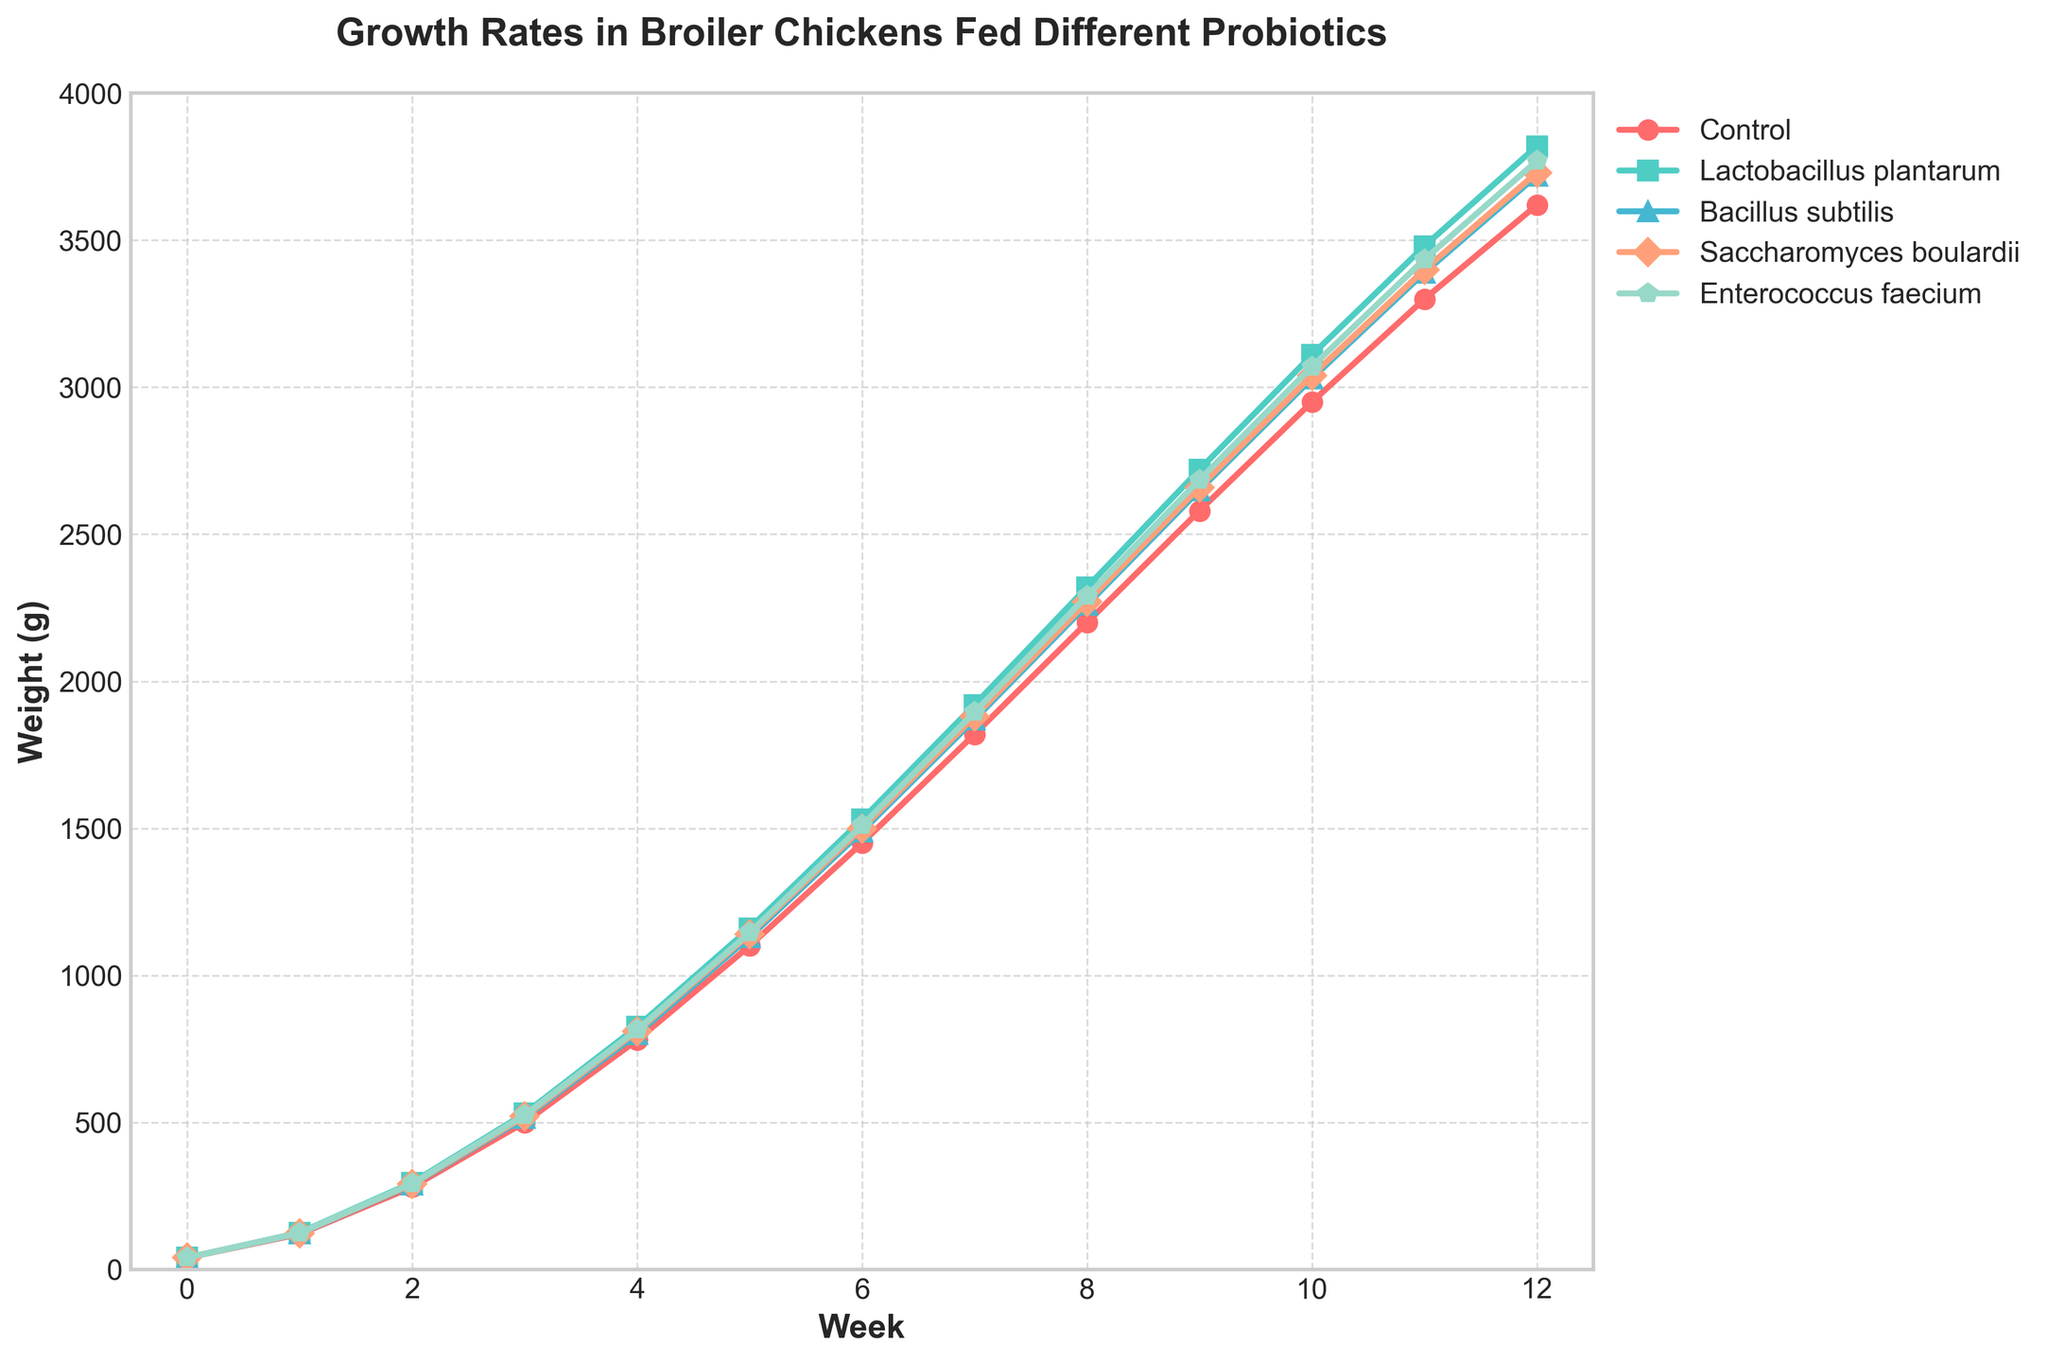What is the difference in weight between broiler chickens fed Control and Lactobacillus plantarum at week 6? To find the difference, we subtract the weight of the Control group from the weight of the Lactobacillus plantarum group at week 6. According to the data, the weights are 1450g (Control) and 1530g (Lactobacillus plantarum). Therefore, 1530 - 1450 = 80g.
Answer: 80g Which probiotic group shows the highest growth rate at week 12? To identify the highest growth rate at week 12, we compare the final weights of all probiotic groups. According to the data, the weights at week 12 are: Lactobacillus plantarum (3820g), Bacillus subtilis (3720g), Saccharomyces boulardii (3730g), and Enterococcus faecium (3770g). Lactobacillus plantarum has the highest weight of 3820g.
Answer: Lactobacillus plantarum At which week does the Enterococcus faecium group surpass the Control group in weight? We need to compare the weights of the Enterococcus faecium group and the Control group at each week to find the first instance where Enterococcus faecium exceeds Control. According to the data, Enterococcus faecium surpasses the Control group at week 3 (525g vs. 500g).
Answer: Week 3 What is the average weight of broiler chickens fed Bacillus subtilis over the 12-week period? To calculate the average weight, we sum the weights for each week and divide by the number of weeks (13 including week 0). According to the data, the weights are: 40, 122, 288, 515, 800, 1130, 1490, 1870, 2260, 2650, 3030, 3390, and 3720. The sum is 23705 and the average is 23705 / 13 ≈ 1823g.
Answer: 1823g Which group shows the least growth rate increment between week 1 and week 2? To find the least growth rate increment, we calculate the difference in weights between week 1 and week 2 for each group. The differences are: Control (280 - 120 = 160g), Lactobacillus plantarum (295 - 125 = 170g), Bacillus subtilis (288 - 122 = 166g), Saccharomyces boulardii (290 - 123 = 167g), Enterococcus faecium (292 - 124 = 168g). The Control group has the smallest increment of 160g.
Answer: Control Describe the color and the marker type used for the Saccharomyces boulardii group in the plot. Observing the visually represented Saccharomyces boulardii group's line in the plot, it's depicted using an orange color with diamond-shaped markers (D) along the line path.
Answer: Orange, Diamond-shaped markers Is there any week where all groups have the same weight? To determine if there is any week where all groups have the same weight, we compare their weights for each week. As per the data, initially at week 0, all groups have the same weight of 40g.
Answer: Week 0 How much more did broiler chickens fed Lactobacillus plantarum weigh than those fed Saccharomyces boulardii at week 9? To find the weight difference at week 9, we subtract the weight of Saccharomyces boulardii from the weight of Lactobacillus plantarum. According to the data, the weights are Lactobacillus plantarum (2720g) and Saccharomyces boulardii (2660g). Therefore, 2720 - 2660 = 60g.
Answer: 60g Compare the growth trends of the Bacillus subtilis and Enterococcus faecium groups. Which probiotic shows more consistent growth? To compare the growth trends, observe the lines' steepness and consistency. Bacillus subtilis shows slightly sharper periodic increments, while Enterococcus faecium displays a smoother and steadier growth curve, suggesting more consistent growth.
Answer: Enterococcus faecium 